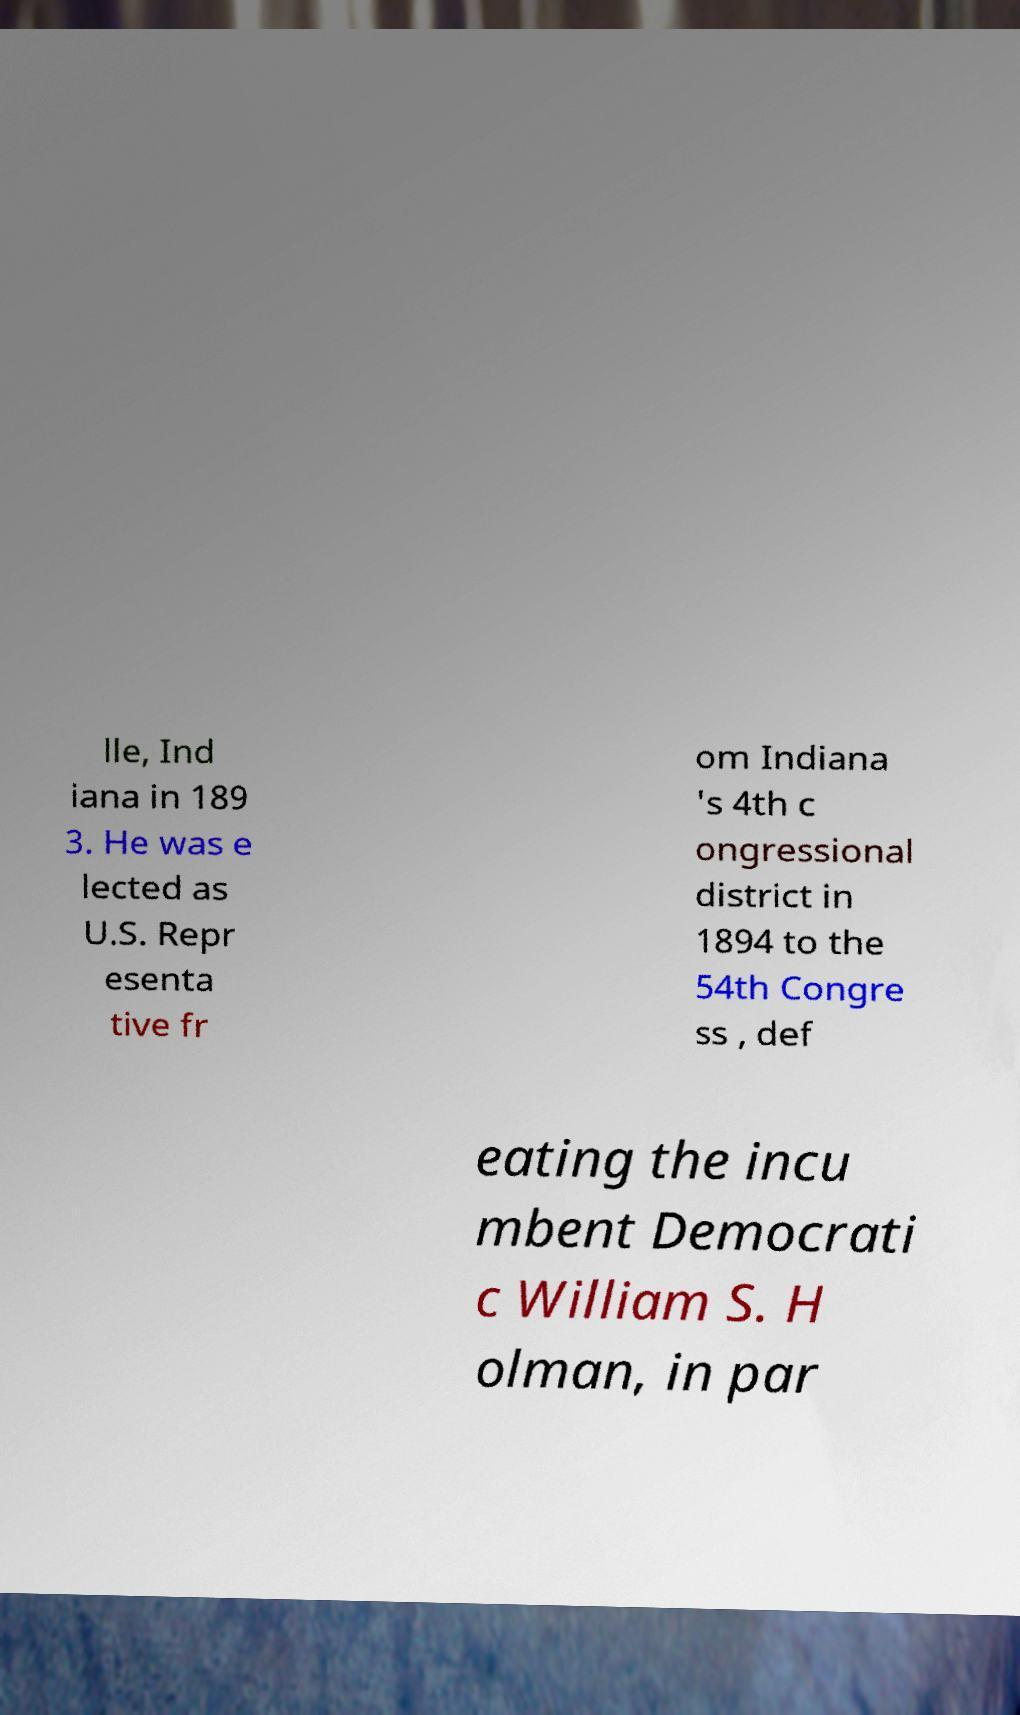Can you read and provide the text displayed in the image?This photo seems to have some interesting text. Can you extract and type it out for me? lle, Ind iana in 189 3. He was e lected as U.S. Repr esenta tive fr om Indiana 's 4th c ongressional district in 1894 to the 54th Congre ss , def eating the incu mbent Democrati c William S. H olman, in par 